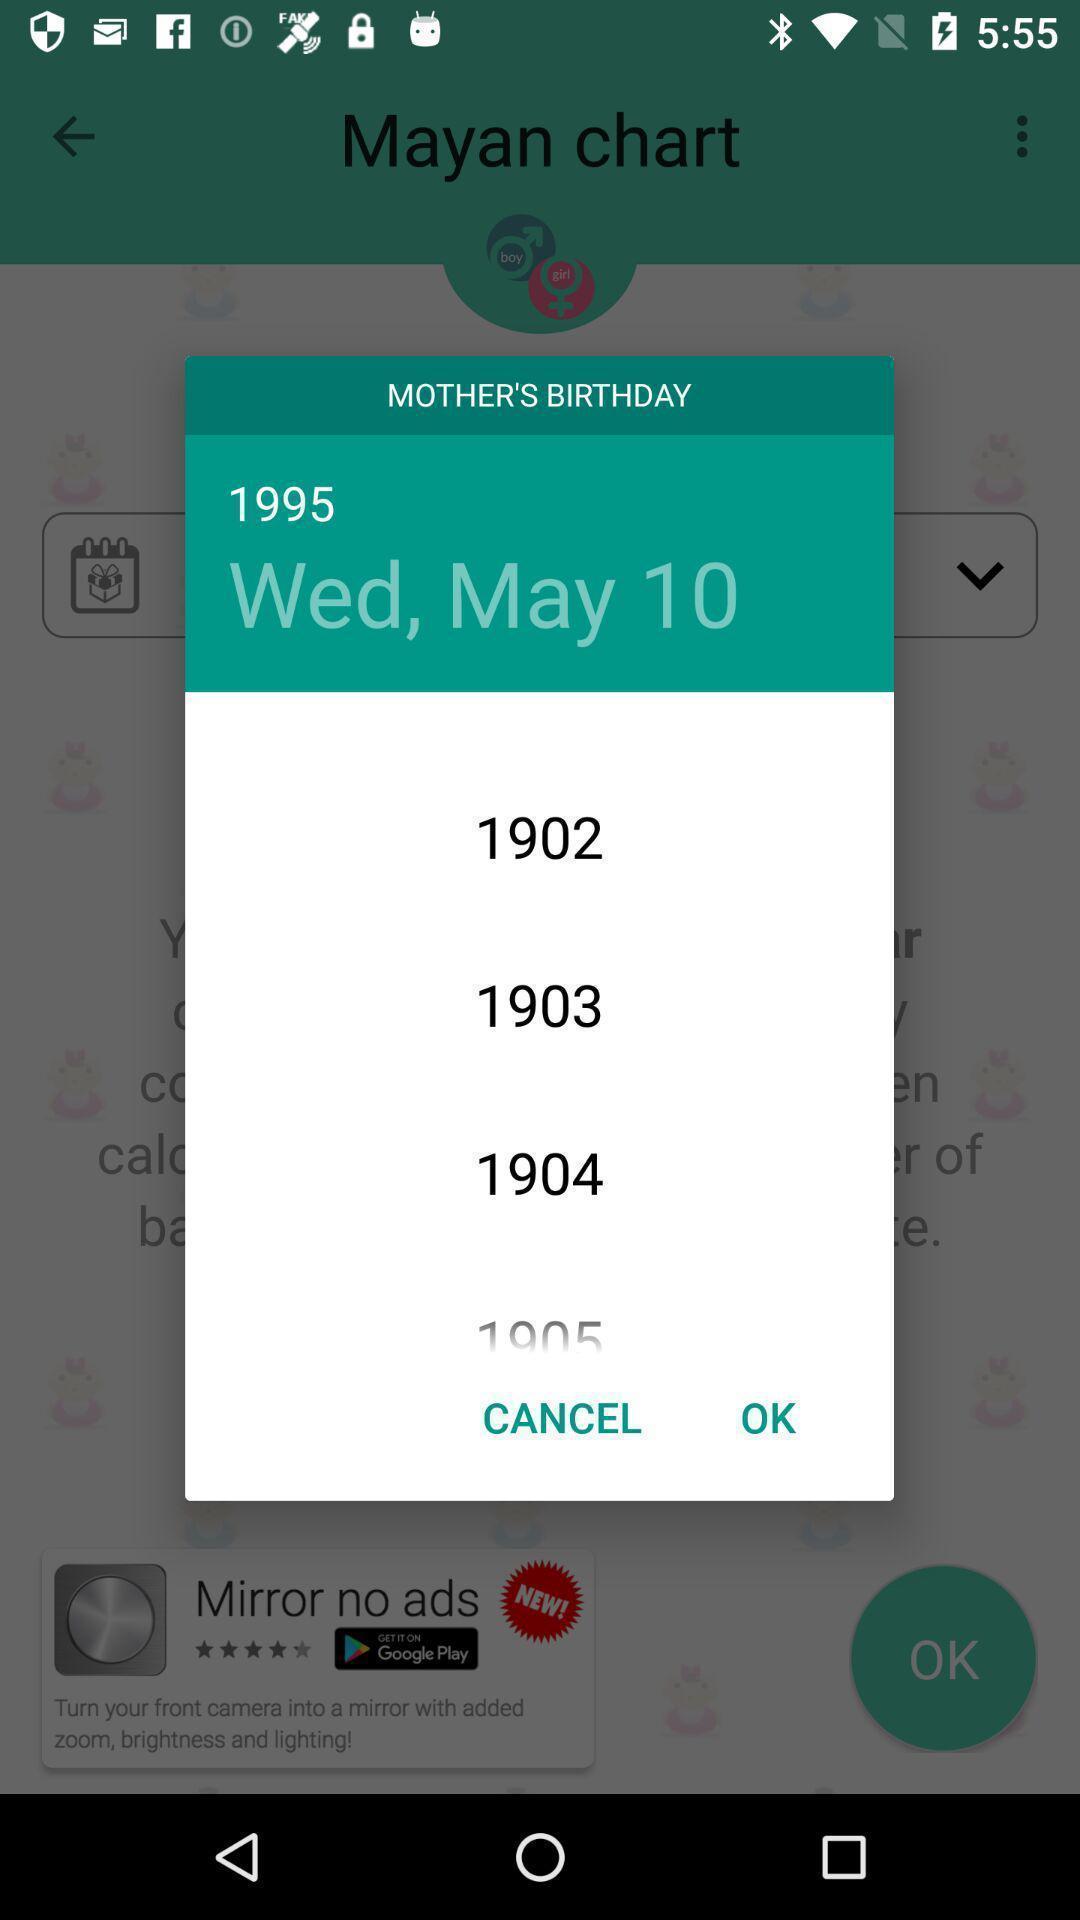Explain what's happening in this screen capture. Popup showing different date and years. 